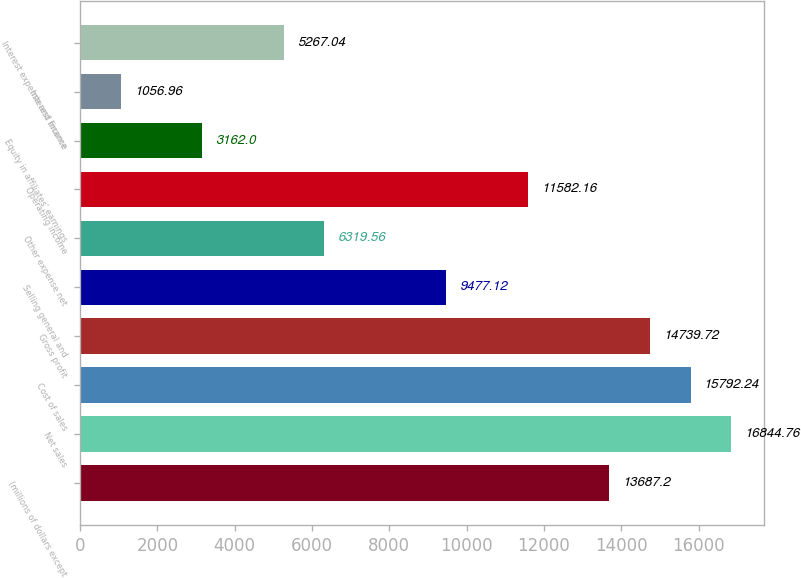<chart> <loc_0><loc_0><loc_500><loc_500><bar_chart><fcel>(millions of dollars except<fcel>Net sales<fcel>Cost of sales<fcel>Gross profit<fcel>Selling general and<fcel>Other expense net<fcel>Operating income<fcel>Equity in affiliates' earnings<fcel>Interest income<fcel>Interest expense and finance<nl><fcel>13687.2<fcel>16844.8<fcel>15792.2<fcel>14739.7<fcel>9477.12<fcel>6319.56<fcel>11582.2<fcel>3162<fcel>1056.96<fcel>5267.04<nl></chart> 